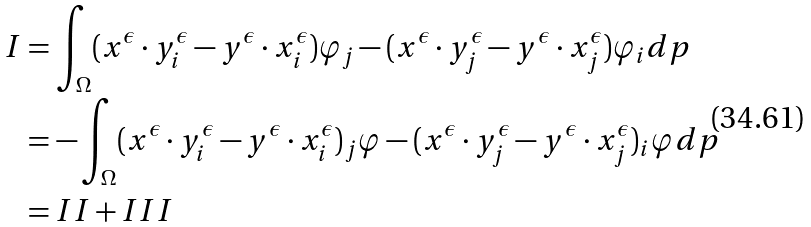<formula> <loc_0><loc_0><loc_500><loc_500>I & = \int _ { \Omega } ( x ^ { \epsilon } \cdot y ^ { \epsilon } _ { i } - y ^ { \epsilon } \cdot x ^ { \epsilon } _ { i } ) \varphi _ { j } - ( x ^ { \epsilon } \cdot y ^ { \epsilon } _ { j } - y ^ { \epsilon } \cdot x ^ { \epsilon } _ { j } ) \varphi _ { i } d p \\ & = - \int _ { \Omega } ( x ^ { \epsilon } \cdot y ^ { \epsilon } _ { i } - y ^ { \epsilon } \cdot x ^ { \epsilon } _ { i } ) _ { j } \varphi - ( x ^ { \epsilon } \cdot y ^ { \epsilon } _ { j } - y ^ { \epsilon } \cdot x ^ { \epsilon } _ { j } ) _ { i } \varphi d p \\ & = I I + I I I</formula> 